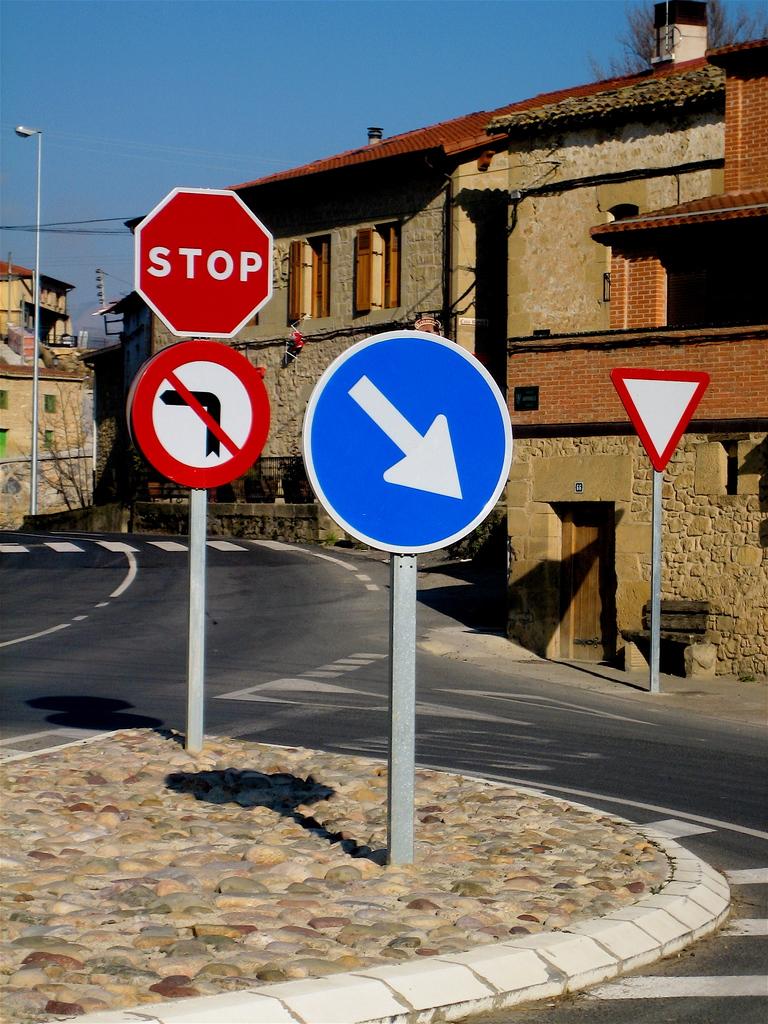What is written on the red octagon?
Give a very brief answer. Stop. 